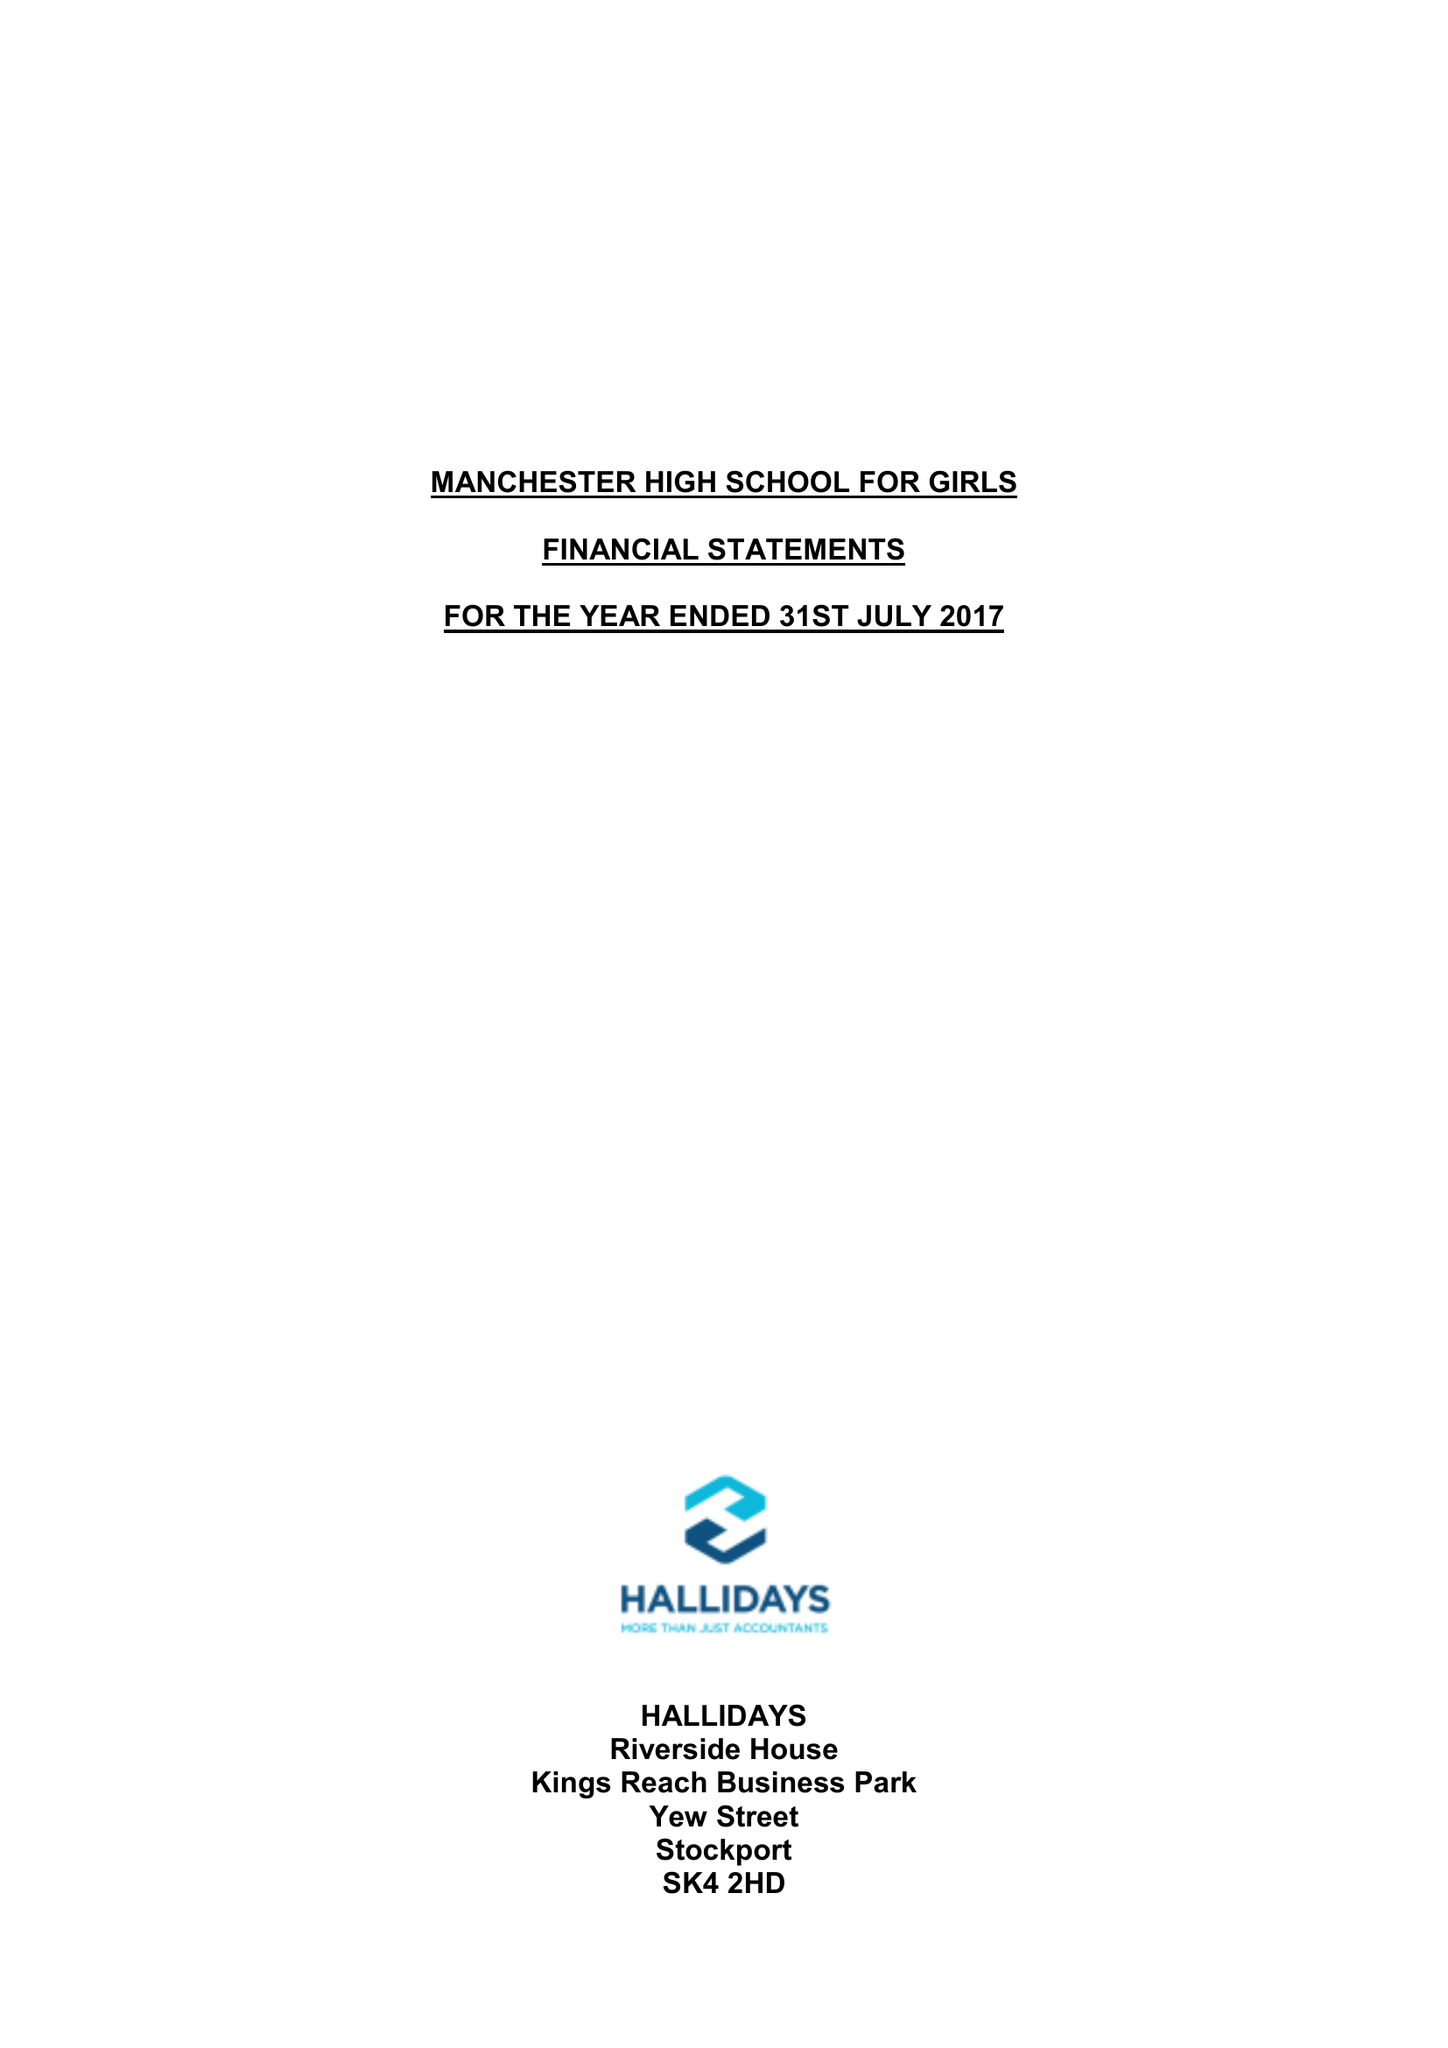What is the value for the charity_name?
Answer the question using a single word or phrase. Manchester High School For Girls 